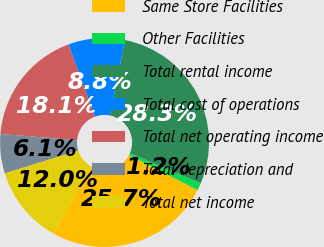<chart> <loc_0><loc_0><loc_500><loc_500><pie_chart><fcel>Same Store Facilities<fcel>Other Facilities<fcel>Total rental income<fcel>Total cost of operations<fcel>Total net operating income<fcel>Total depreciation and<fcel>Total net income<nl><fcel>25.68%<fcel>1.15%<fcel>28.25%<fcel>8.76%<fcel>18.07%<fcel>6.08%<fcel>12.0%<nl></chart> 